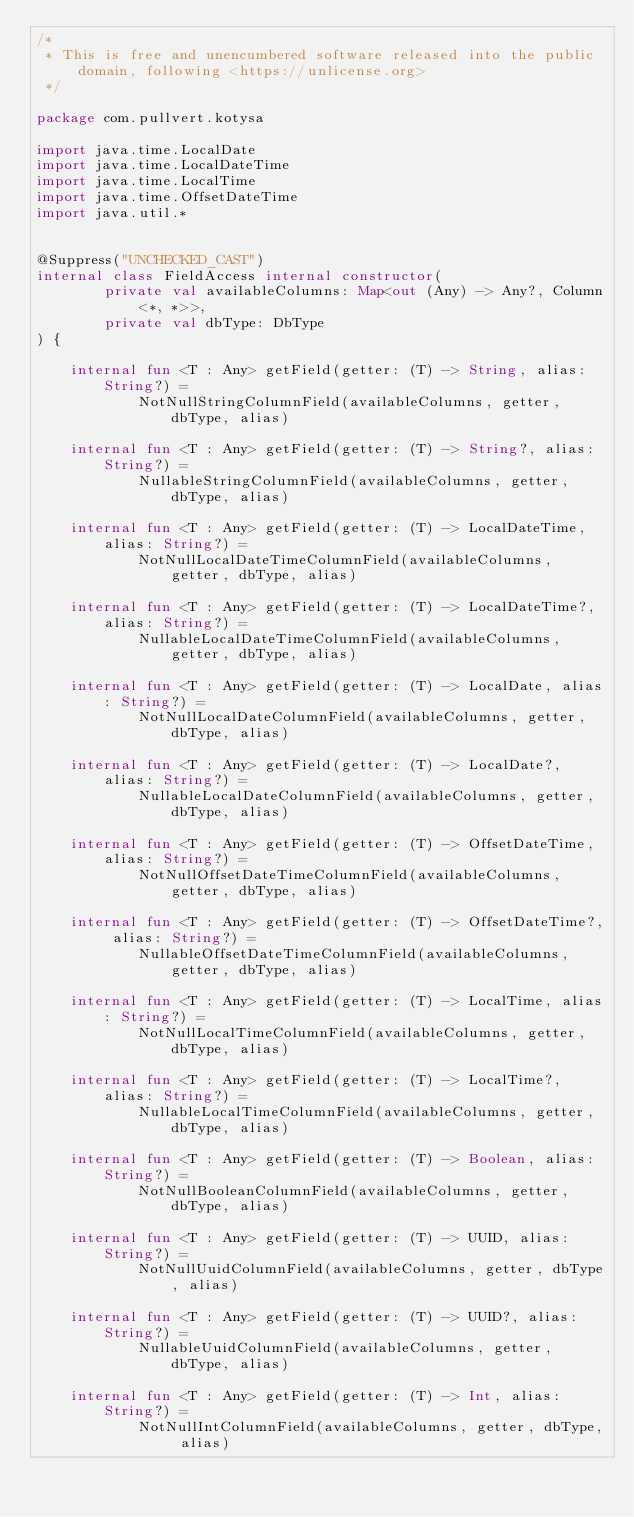<code> <loc_0><loc_0><loc_500><loc_500><_Kotlin_>/*
 * This is free and unencumbered software released into the public domain, following <https://unlicense.org>
 */

package com.pullvert.kotysa

import java.time.LocalDate
import java.time.LocalDateTime
import java.time.LocalTime
import java.time.OffsetDateTime
import java.util.*


@Suppress("UNCHECKED_CAST")
internal class FieldAccess internal constructor(
        private val availableColumns: Map<out (Any) -> Any?, Column<*, *>>,
        private val dbType: DbType
) {

    internal fun <T : Any> getField(getter: (T) -> String, alias: String?) =
            NotNullStringColumnField(availableColumns, getter, dbType, alias)

    internal fun <T : Any> getField(getter: (T) -> String?, alias: String?) =
            NullableStringColumnField(availableColumns, getter, dbType, alias)

    internal fun <T : Any> getField(getter: (T) -> LocalDateTime, alias: String?) =
            NotNullLocalDateTimeColumnField(availableColumns, getter, dbType, alias)

    internal fun <T : Any> getField(getter: (T) -> LocalDateTime?, alias: String?) =
            NullableLocalDateTimeColumnField(availableColumns, getter, dbType, alias)

    internal fun <T : Any> getField(getter: (T) -> LocalDate, alias: String?) =
            NotNullLocalDateColumnField(availableColumns, getter, dbType, alias)

    internal fun <T : Any> getField(getter: (T) -> LocalDate?, alias: String?) =
            NullableLocalDateColumnField(availableColumns, getter, dbType, alias)

    internal fun <T : Any> getField(getter: (T) -> OffsetDateTime, alias: String?) =
            NotNullOffsetDateTimeColumnField(availableColumns, getter, dbType, alias)

    internal fun <T : Any> getField(getter: (T) -> OffsetDateTime?, alias: String?) =
            NullableOffsetDateTimeColumnField(availableColumns, getter, dbType, alias)

    internal fun <T : Any> getField(getter: (T) -> LocalTime, alias: String?) =
            NotNullLocalTimeColumnField(availableColumns, getter, dbType, alias)

    internal fun <T : Any> getField(getter: (T) -> LocalTime?, alias: String?) =
            NullableLocalTimeColumnField(availableColumns, getter, dbType, alias)

    internal fun <T : Any> getField(getter: (T) -> Boolean, alias: String?) =
            NotNullBooleanColumnField(availableColumns, getter, dbType, alias)

    internal fun <T : Any> getField(getter: (T) -> UUID, alias: String?) =
            NotNullUuidColumnField(availableColumns, getter, dbType, alias)

    internal fun <T : Any> getField(getter: (T) -> UUID?, alias: String?) =
            NullableUuidColumnField(availableColumns, getter, dbType, alias)

    internal fun <T : Any> getField(getter: (T) -> Int, alias: String?) =
            NotNullIntColumnField(availableColumns, getter, dbType, alias)
</code> 